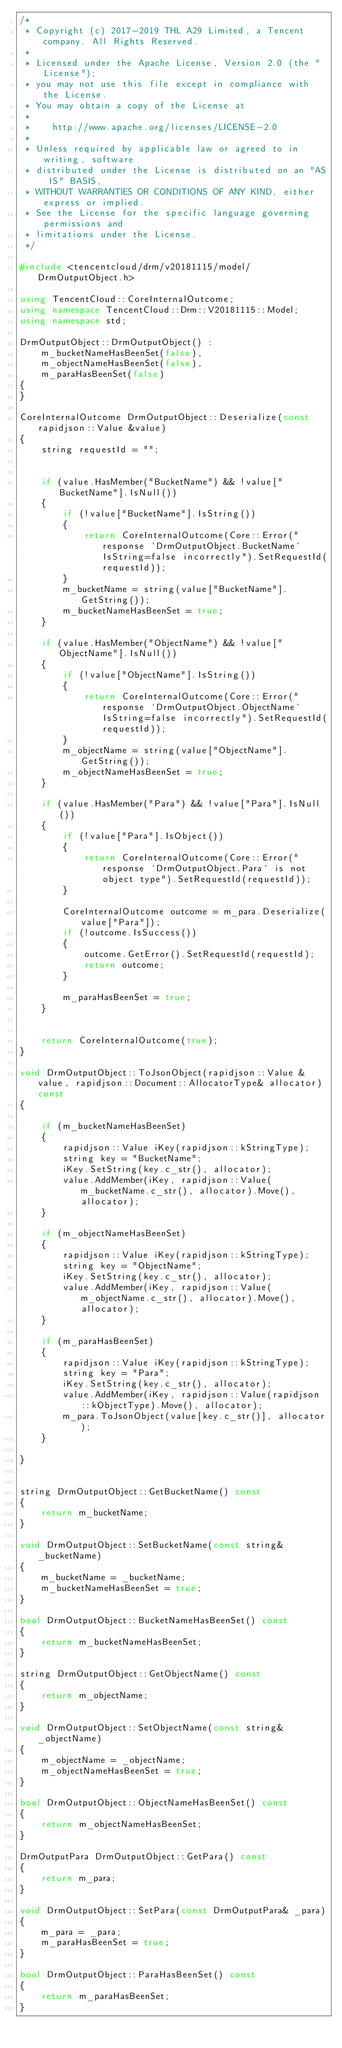<code> <loc_0><loc_0><loc_500><loc_500><_C++_>/*
 * Copyright (c) 2017-2019 THL A29 Limited, a Tencent company. All Rights Reserved.
 *
 * Licensed under the Apache License, Version 2.0 (the "License");
 * you may not use this file except in compliance with the License.
 * You may obtain a copy of the License at
 *
 *    http://www.apache.org/licenses/LICENSE-2.0
 *
 * Unless required by applicable law or agreed to in writing, software
 * distributed under the License is distributed on an "AS IS" BASIS,
 * WITHOUT WARRANTIES OR CONDITIONS OF ANY KIND, either express or implied.
 * See the License for the specific language governing permissions and
 * limitations under the License.
 */

#include <tencentcloud/drm/v20181115/model/DrmOutputObject.h>

using TencentCloud::CoreInternalOutcome;
using namespace TencentCloud::Drm::V20181115::Model;
using namespace std;

DrmOutputObject::DrmOutputObject() :
    m_bucketNameHasBeenSet(false),
    m_objectNameHasBeenSet(false),
    m_paraHasBeenSet(false)
{
}

CoreInternalOutcome DrmOutputObject::Deserialize(const rapidjson::Value &value)
{
    string requestId = "";


    if (value.HasMember("BucketName") && !value["BucketName"].IsNull())
    {
        if (!value["BucketName"].IsString())
        {
            return CoreInternalOutcome(Core::Error("response `DrmOutputObject.BucketName` IsString=false incorrectly").SetRequestId(requestId));
        }
        m_bucketName = string(value["BucketName"].GetString());
        m_bucketNameHasBeenSet = true;
    }

    if (value.HasMember("ObjectName") && !value["ObjectName"].IsNull())
    {
        if (!value["ObjectName"].IsString())
        {
            return CoreInternalOutcome(Core::Error("response `DrmOutputObject.ObjectName` IsString=false incorrectly").SetRequestId(requestId));
        }
        m_objectName = string(value["ObjectName"].GetString());
        m_objectNameHasBeenSet = true;
    }

    if (value.HasMember("Para") && !value["Para"].IsNull())
    {
        if (!value["Para"].IsObject())
        {
            return CoreInternalOutcome(Core::Error("response `DrmOutputObject.Para` is not object type").SetRequestId(requestId));
        }

        CoreInternalOutcome outcome = m_para.Deserialize(value["Para"]);
        if (!outcome.IsSuccess())
        {
            outcome.GetError().SetRequestId(requestId);
            return outcome;
        }

        m_paraHasBeenSet = true;
    }


    return CoreInternalOutcome(true);
}

void DrmOutputObject::ToJsonObject(rapidjson::Value &value, rapidjson::Document::AllocatorType& allocator) const
{

    if (m_bucketNameHasBeenSet)
    {
        rapidjson::Value iKey(rapidjson::kStringType);
        string key = "BucketName";
        iKey.SetString(key.c_str(), allocator);
        value.AddMember(iKey, rapidjson::Value(m_bucketName.c_str(), allocator).Move(), allocator);
    }

    if (m_objectNameHasBeenSet)
    {
        rapidjson::Value iKey(rapidjson::kStringType);
        string key = "ObjectName";
        iKey.SetString(key.c_str(), allocator);
        value.AddMember(iKey, rapidjson::Value(m_objectName.c_str(), allocator).Move(), allocator);
    }

    if (m_paraHasBeenSet)
    {
        rapidjson::Value iKey(rapidjson::kStringType);
        string key = "Para";
        iKey.SetString(key.c_str(), allocator);
        value.AddMember(iKey, rapidjson::Value(rapidjson::kObjectType).Move(), allocator);
        m_para.ToJsonObject(value[key.c_str()], allocator);
    }

}


string DrmOutputObject::GetBucketName() const
{
    return m_bucketName;
}

void DrmOutputObject::SetBucketName(const string& _bucketName)
{
    m_bucketName = _bucketName;
    m_bucketNameHasBeenSet = true;
}

bool DrmOutputObject::BucketNameHasBeenSet() const
{
    return m_bucketNameHasBeenSet;
}

string DrmOutputObject::GetObjectName() const
{
    return m_objectName;
}

void DrmOutputObject::SetObjectName(const string& _objectName)
{
    m_objectName = _objectName;
    m_objectNameHasBeenSet = true;
}

bool DrmOutputObject::ObjectNameHasBeenSet() const
{
    return m_objectNameHasBeenSet;
}

DrmOutputPara DrmOutputObject::GetPara() const
{
    return m_para;
}

void DrmOutputObject::SetPara(const DrmOutputPara& _para)
{
    m_para = _para;
    m_paraHasBeenSet = true;
}

bool DrmOutputObject::ParaHasBeenSet() const
{
    return m_paraHasBeenSet;
}

</code> 